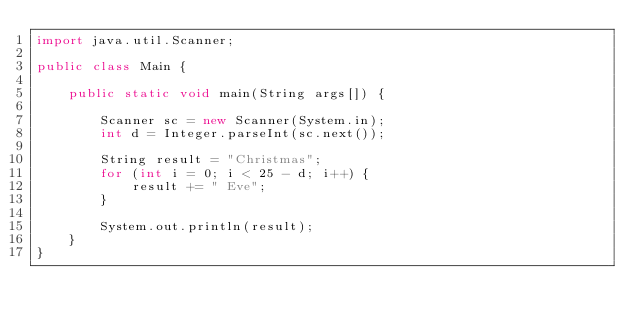Convert code to text. <code><loc_0><loc_0><loc_500><loc_500><_Java_>import java.util.Scanner;

public class Main {

    public static void main(String args[]) {

        Scanner sc = new Scanner(System.in);
        int d = Integer.parseInt(sc.next());

        String result = "Christmas";
        for (int i = 0; i < 25 - d; i++) {
            result += " Eve";
        }

        System.out.println(result);
    }
}</code> 